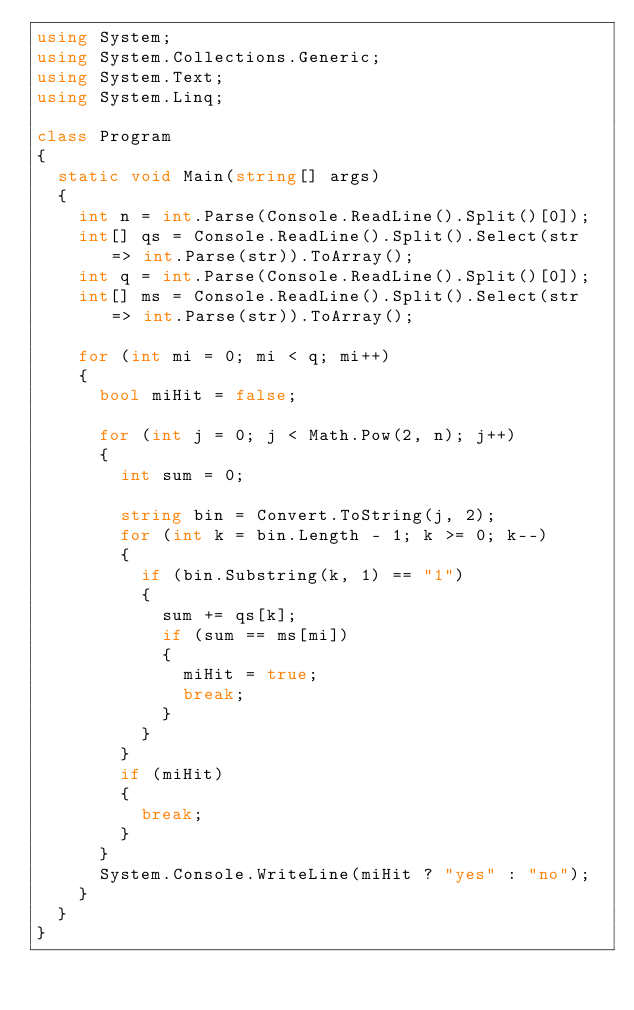<code> <loc_0><loc_0><loc_500><loc_500><_C#_>using System;
using System.Collections.Generic;
using System.Text;
using System.Linq;

class Program
{
	static void Main(string[] args)
	{
		int n = int.Parse(Console.ReadLine().Split()[0]);
		int[] qs = Console.ReadLine().Split().Select(str => int.Parse(str)).ToArray();
		int q = int.Parse(Console.ReadLine().Split()[0]);
		int[] ms = Console.ReadLine().Split().Select(str => int.Parse(str)).ToArray();

		for (int mi = 0; mi < q; mi++)
		{
			bool miHit = false;
			
			for (int j = 0; j < Math.Pow(2, n); j++)
			{
				int sum = 0;

				string bin = Convert.ToString(j, 2);
				for (int k = bin.Length - 1; k >= 0; k--)
				{
					if (bin.Substring(k, 1) == "1")
					{
						sum += qs[k];
						if (sum == ms[mi])
						{
							miHit = true;
							break;
						}
					}
				}
				if (miHit)
				{
					break;
				}
			}
			System.Console.WriteLine(miHit ? "yes" : "no");
		}
	}
}

</code> 